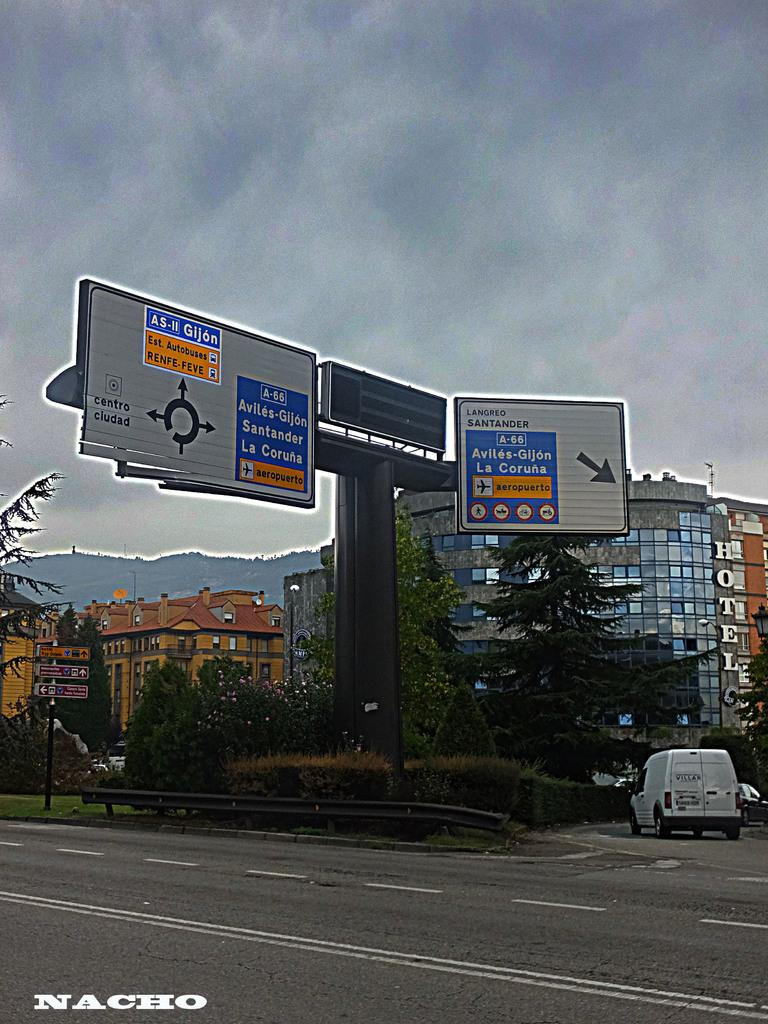<image>
Relay a brief, clear account of the picture shown. Roadsigns show the directions to reach various locations nicluding the airport. 